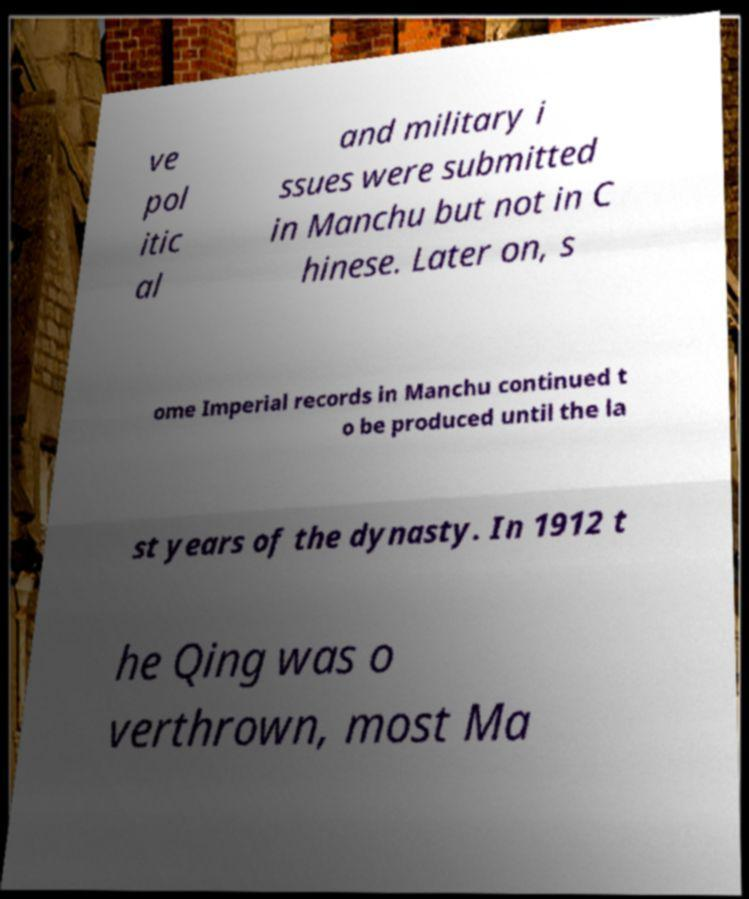Can you accurately transcribe the text from the provided image for me? ve pol itic al and military i ssues were submitted in Manchu but not in C hinese. Later on, s ome Imperial records in Manchu continued t o be produced until the la st years of the dynasty. In 1912 t he Qing was o verthrown, most Ma 